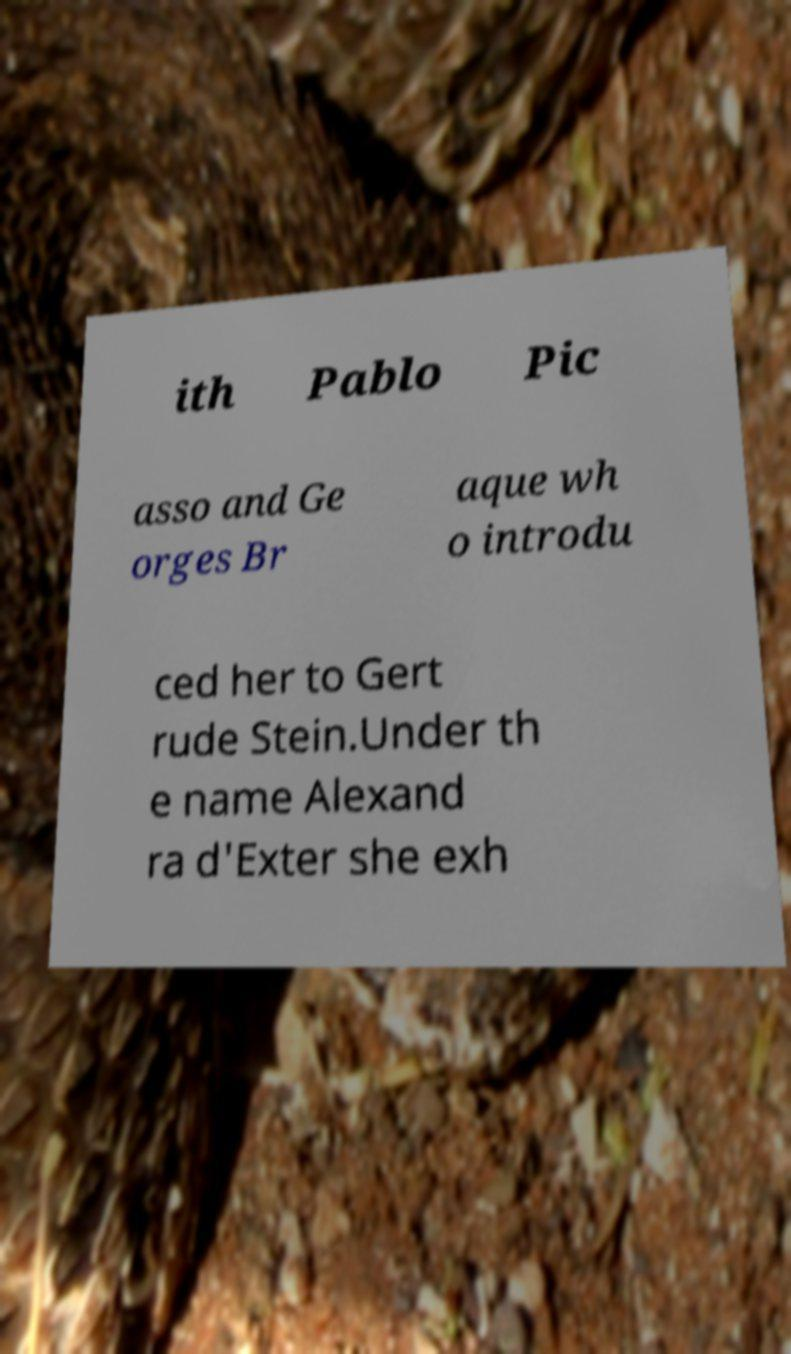What messages or text are displayed in this image? I need them in a readable, typed format. ith Pablo Pic asso and Ge orges Br aque wh o introdu ced her to Gert rude Stein.Under th e name Alexand ra d'Exter she exh 